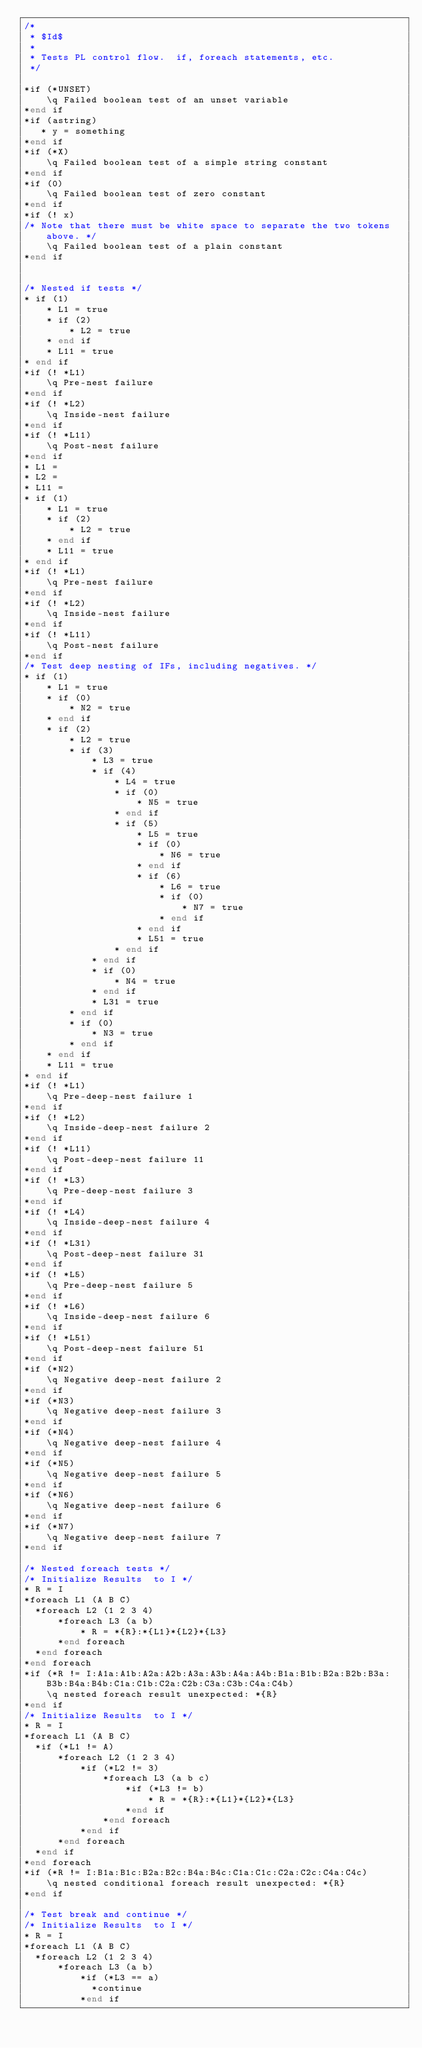Convert code to text. <code><loc_0><loc_0><loc_500><loc_500><_SQL_>/*
 * $Id$
 *
 * Tests PL control flow.  if, foreach statements, etc.
 */

*if (*UNSET)
    \q Failed boolean test of an unset variable
*end if
*if (astring)
   * y = something
*end if
*if (*X)
    \q Failed boolean test of a simple string constant
*end if
*if (0)
    \q Failed boolean test of zero constant
*end if
*if (! x)
/* Note that there must be white space to separate the two tokens above. */
    \q Failed boolean test of a plain constant
*end if


/* Nested if tests */
* if (1)
    * L1 = true
    * if (2)
        * L2 = true
    * end if
    * L11 = true
* end if
*if (! *L1)
    \q Pre-nest failure
*end if
*if (! *L2)
    \q Inside-nest failure
*end if
*if (! *L11)
    \q Post-nest failure
*end if
* L1 =
* L2 =
* L11 =
* if (1)
    * L1 = true
    * if (2)
        * L2 = true
    * end if
    * L11 = true
* end if
*if (! *L1)
    \q Pre-nest failure
*end if
*if (! *L2)
    \q Inside-nest failure
*end if
*if (! *L11)
    \q Post-nest failure
*end if
/* Test deep nesting of IFs, including negatives. */
* if (1)
    * L1 = true
    * if (0)
        * N2 = true
    * end if
    * if (2)
        * L2 = true
        * if (3)
            * L3 = true
            * if (4)
                * L4 = true
                * if (0)
                    * N5 = true
                * end if
                * if (5)
                    * L5 = true
                    * if (0)
                        * N6 = true
                    * end if
                    * if (6)
                        * L6 = true
                        * if (0)
                            * N7 = true
                        * end if
                    * end if
                    * L51 = true
                * end if
            * end if
            * if (0)
                * N4 = true
            * end if
            * L31 = true
        * end if
        * if (0)
            * N3 = true
        * end if
    * end if
    * L11 = true
* end if
*if (! *L1)
    \q Pre-deep-nest failure 1
*end if
*if (! *L2)
    \q Inside-deep-nest failure 2
*end if
*if (! *L11)
    \q Post-deep-nest failure 11
*end if
*if (! *L3)
    \q Pre-deep-nest failure 3
*end if
*if (! *L4)
    \q Inside-deep-nest failure 4
*end if
*if (! *L31)
    \q Post-deep-nest failure 31
*end if
*if (! *L5)
    \q Pre-deep-nest failure 5
*end if
*if (! *L6)
    \q Inside-deep-nest failure 6
*end if
*if (! *L51)
    \q Post-deep-nest failure 51
*end if
*if (*N2)
    \q Negative deep-nest failure 2
*end if
*if (*N3)
    \q Negative deep-nest failure 3
*end if
*if (*N4)
    \q Negative deep-nest failure 4
*end if
*if (*N5)
    \q Negative deep-nest failure 5
*end if
*if (*N6)
    \q Negative deep-nest failure 6
*end if
*if (*N7)
    \q Negative deep-nest failure 7
*end if

/* Nested foreach tests */
/* Initialize Results  to I */
* R = I
*foreach L1 (A B C)
  *foreach L2 (1 2 3 4)
      *foreach L3 (a b)
	      * R = *{R}:*{L1}*{L2}*{L3}
	  *end foreach
  *end foreach
*end foreach
*if (*R != I:A1a:A1b:A2a:A2b:A3a:A3b:A4a:A4b:B1a:B1b:B2a:B2b:B3a:B3b:B4a:B4b:C1a:C1b:C2a:C2b:C3a:C3b:C4a:C4b)
    \q nested foreach result unexpected: *{R}
*end if
/* Initialize Results  to I */
* R = I
*foreach L1 (A B C)
  *if (*L1 != A)
	  *foreach L2 (1 2 3 4)
		  *if (*L2 != 3)
			  *foreach L3 (a b c)
				  *if (*L3 != b)
					  * R = *{R}:*{L1}*{L2}*{L3}
				  *end if
			  *end foreach
		  *end if
	  *end foreach
  *end if
*end foreach
*if (*R != I:B1a:B1c:B2a:B2c:B4a:B4c:C1a:C1c:C2a:C2c:C4a:C4c)
    \q nested conditional foreach result unexpected: *{R}
*end if

/* Test break and continue */
/* Initialize Results  to I */
* R = I
*foreach L1 (A B C)
  *foreach L2 (1 2 3 4)
      *foreach L3 (a b)
          *if (*L3 == a)
            *continue
          *end if</code> 